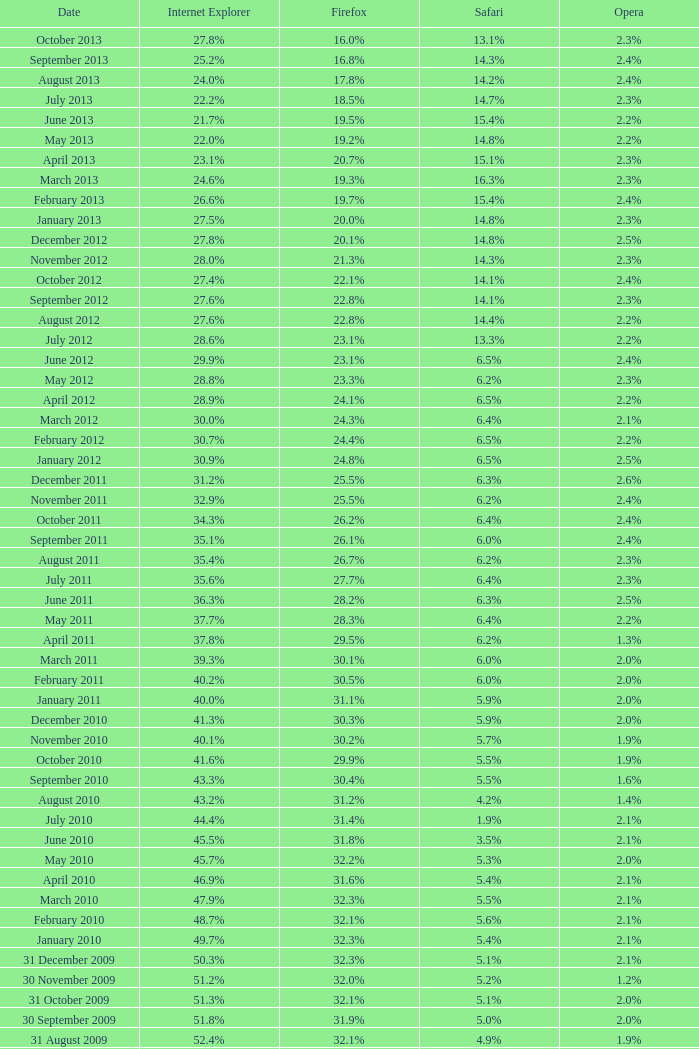What is the date when internet explorer was 62.2% 31 January 2008. 